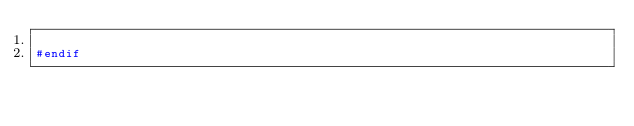<code> <loc_0><loc_0><loc_500><loc_500><_C_>
#endif

</code> 